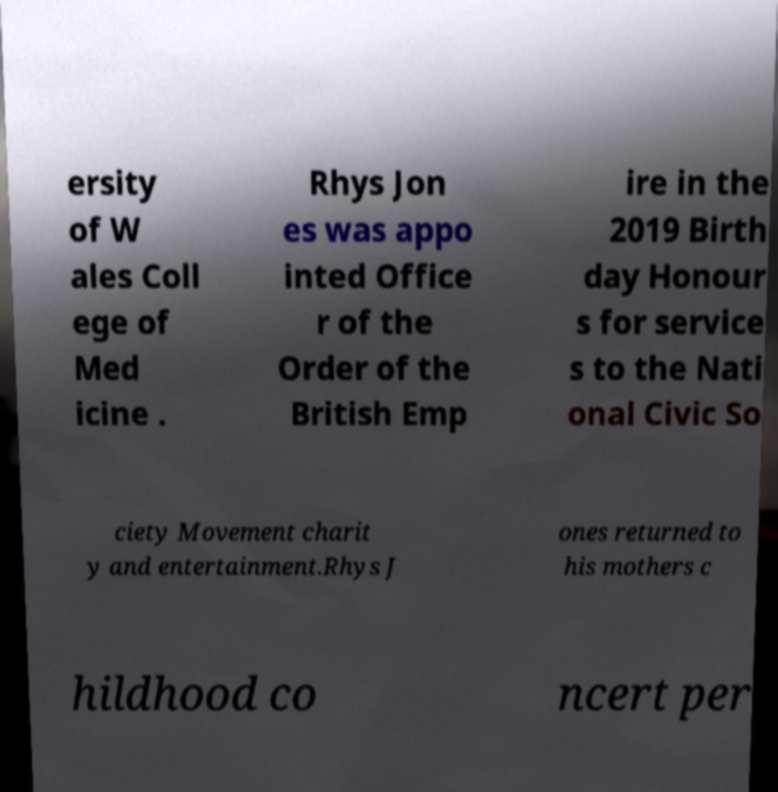Please identify and transcribe the text found in this image. ersity of W ales Coll ege of Med icine . Rhys Jon es was appo inted Office r of the Order of the British Emp ire in the 2019 Birth day Honour s for service s to the Nati onal Civic So ciety Movement charit y and entertainment.Rhys J ones returned to his mothers c hildhood co ncert per 